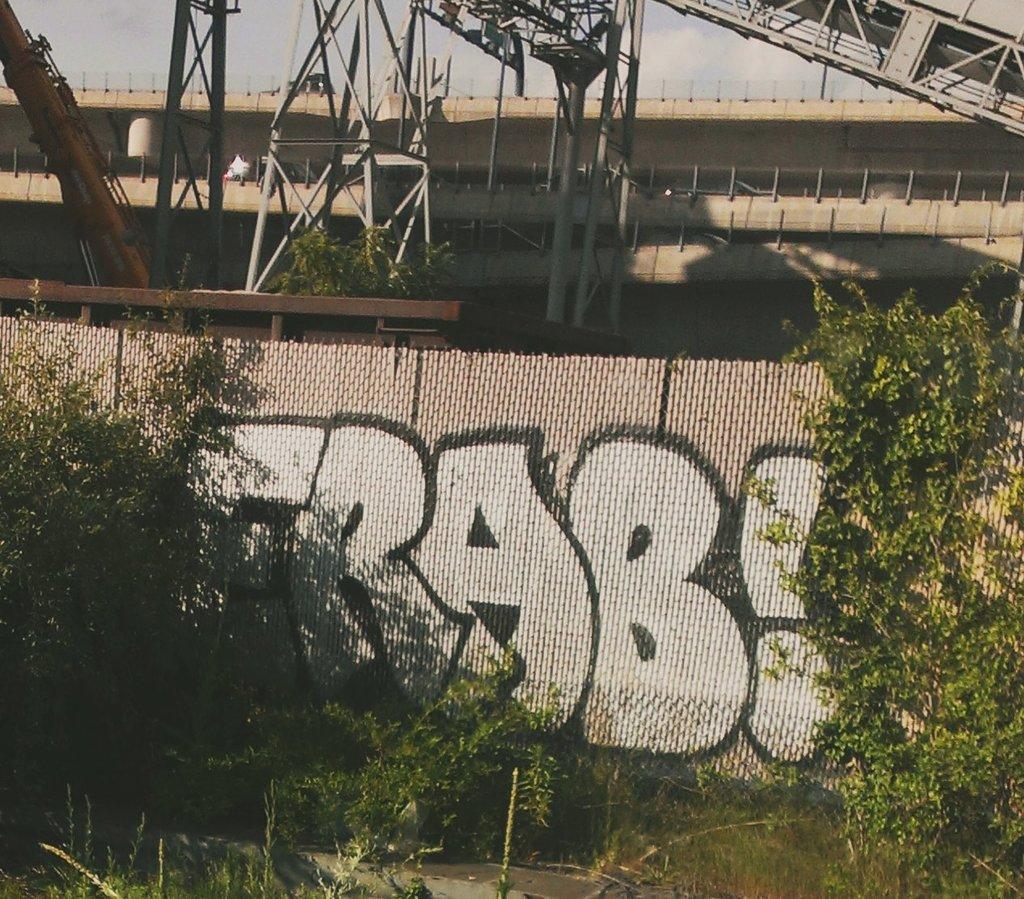Could you give a brief overview of what you see in this image? In this image we can see a building, there are some trees, towers, plants, crane and the wall, in the background, we can see the sky with clouds. 